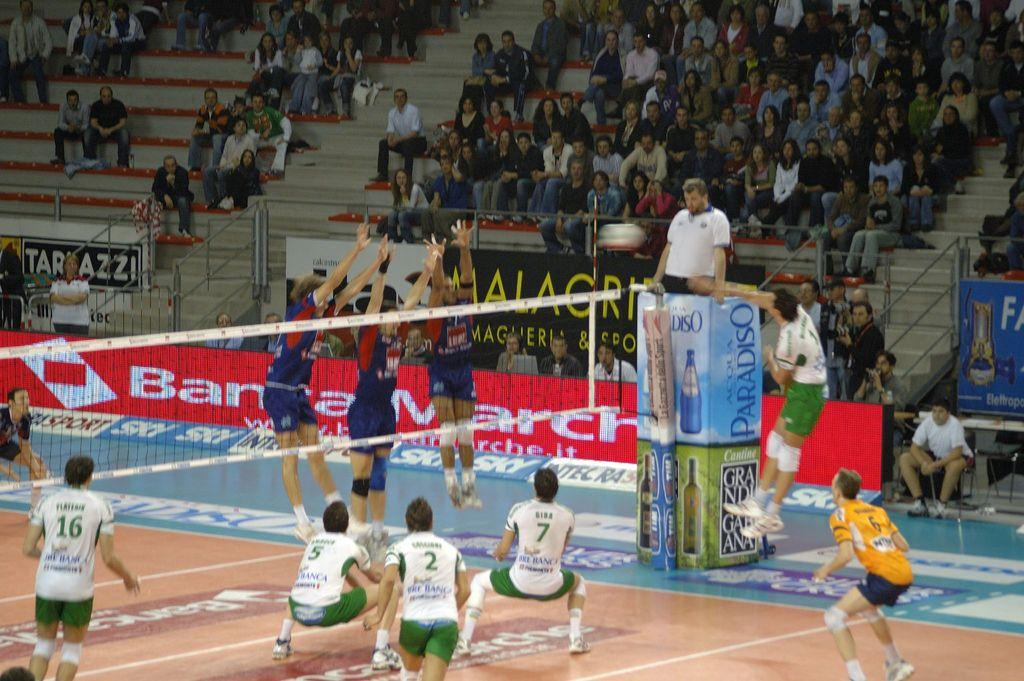Provide a one-sentence caption for the provided image. The referee is up on a stand advertising Acqua Paradiso. 